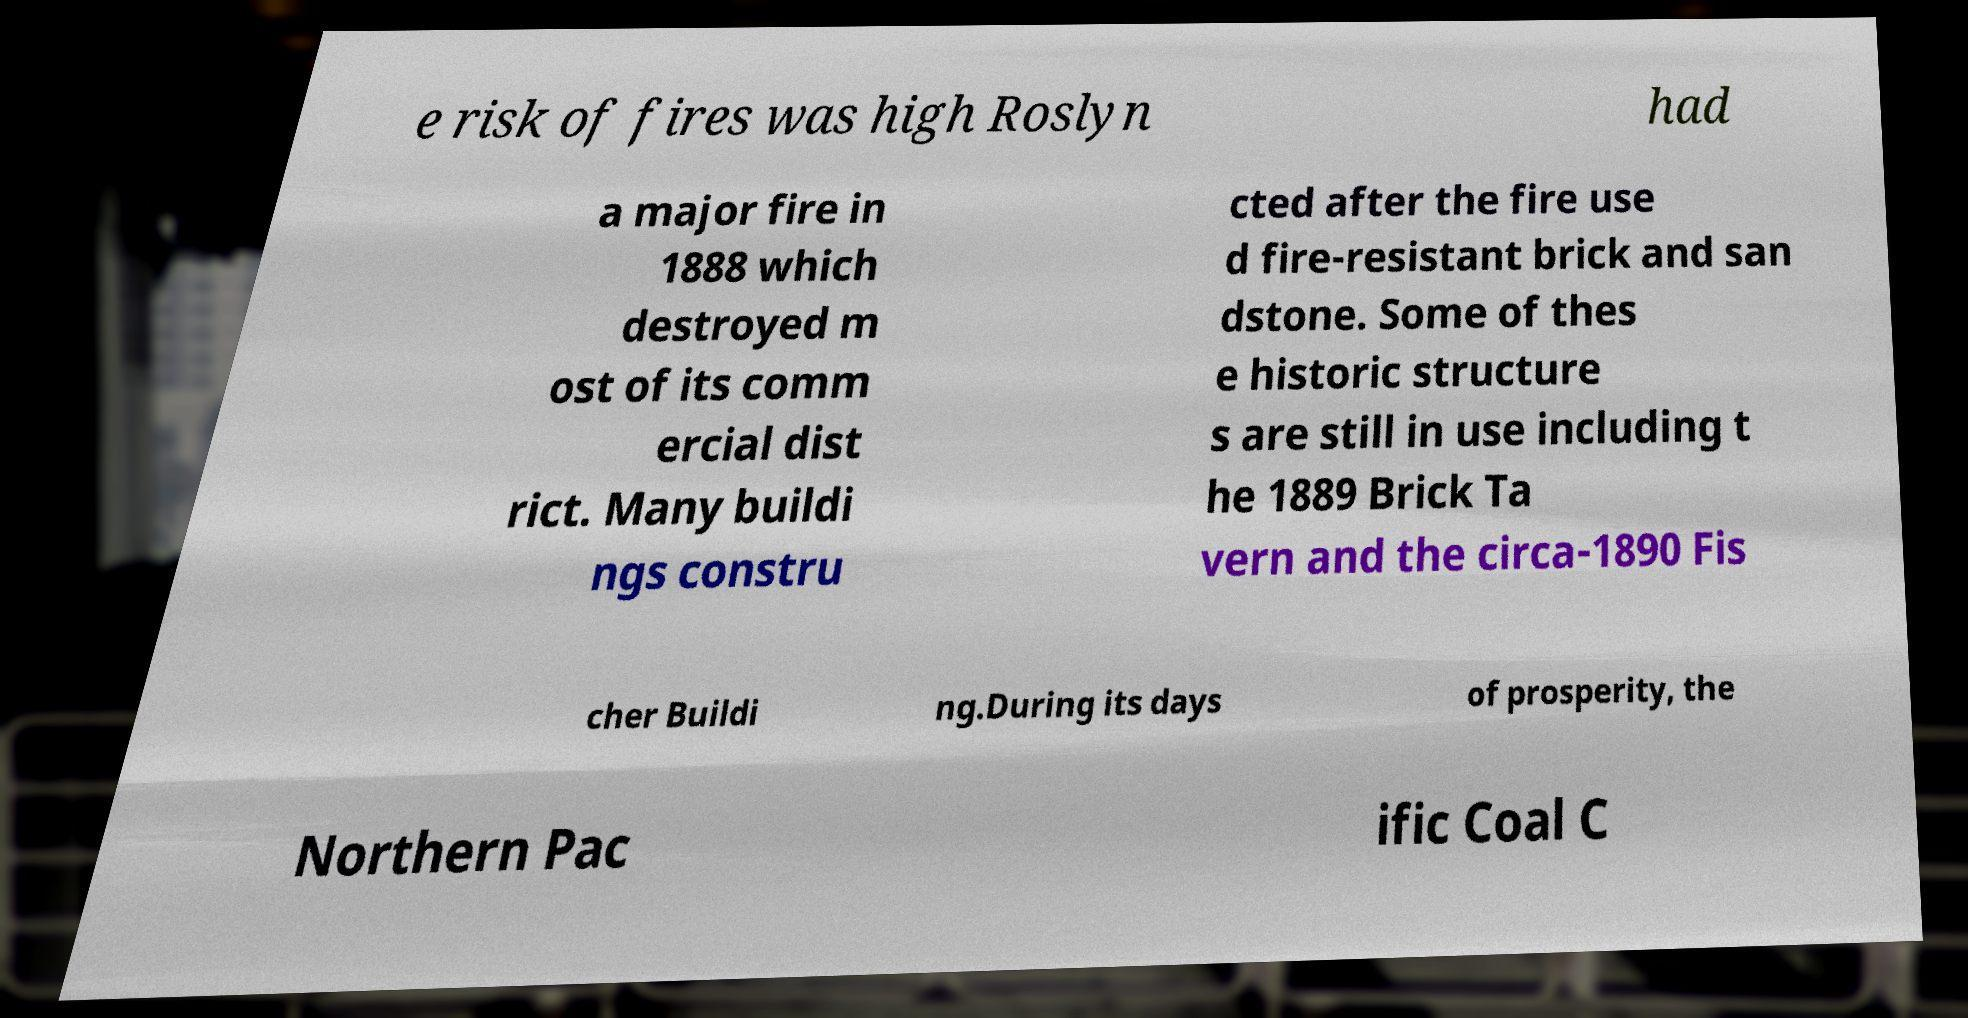There's text embedded in this image that I need extracted. Can you transcribe it verbatim? e risk of fires was high Roslyn had a major fire in 1888 which destroyed m ost of its comm ercial dist rict. Many buildi ngs constru cted after the fire use d fire-resistant brick and san dstone. Some of thes e historic structure s are still in use including t he 1889 Brick Ta vern and the circa-1890 Fis cher Buildi ng.During its days of prosperity, the Northern Pac ific Coal C 